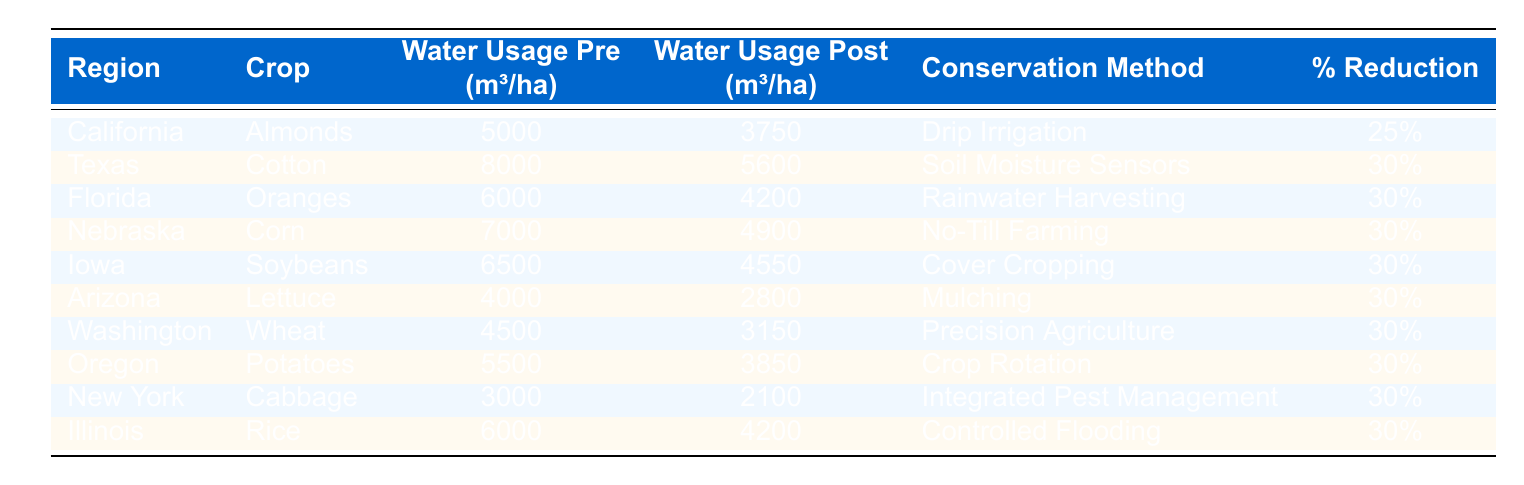What is the water usage per hectare for almonds in California before conservation methods? The table shows that the water usage for almonds in California before conservation methods was 5000 m³/ha.
Answer: 5000 m³/ha What is the percentage reduction in water usage for wheat in Washington after implementing conservation methods? The table indicates that the percentage reduction in water usage for wheat in Washington is 30%.
Answer: 30% Which conservation method resulted in the lowest post-conservation water usage? By analyzing the table, lettuce in Arizona has the lowest post-conservation water usage at 2800 m³/ha.
Answer: 2800 m³/ha What is the average percentage reduction in water usage across all regions listed in the table? To find the average, sum the percentage reductions: 25 + 30 + 30 + 30 + 30 + 30 + 30 + 30 + 30 + 30 =  295, then divide by the number of regions (10), giving an average of 29.5%.
Answer: 29.5% Is the water usage for rice in Illinois higher or lower than that for oranges in Florida after conservation methods? The water usage for rice in Illinois after conservation is 4200 m³/ha, while for oranges it is 4200 m³/ha. Thus, they are equal.
Answer: Equal How much water is saved in cubic meters per hectare for corn in Nebraska after conservation methods? The water usage for corn pre-conservation is 7000 m³/ha and post-conservation is 4900 m³/ha. The difference is 7000 - 4900 = 2100 m³/ha saved.
Answer: 2100 m³/ha Which region has the highest water usage pre-conservation and what is that usage? The table shows Texas has the highest water usage pre-conservation at 8000 m³/ha for cotton.
Answer: 8000 m³/ha What is the total water usage reduction for oranges and rice combined? For oranges, the reduction is 6000 - 4200 = 1800 m³/ha and for rice, it is 6000 - 4200 = 1800 m³/ha. Hence, total reduction is 1800 + 1800 = 3600 m³/ha.
Answer: 3600 m³/ha Which crop in which region experienced the highest water usage reduction percentage? Checking the table, all crops apart from almonds have 30% reduction with the highest water usage being in cotton, so cotton in Texas experienced a reduction of 30%.
Answer: 30% What could be inferred about the effectiveness of 'Drip Irrigation' compared to other conservation methods? 'Drip Irrigation' achieved a 25% reduction for almonds, which is lower than the 30% reduction achieved by other methods; thus, it may be inferred that it is marginally less effective compared to the other methods listed.
Answer: Less effective How does the post-conservation water usage for potatoes in Oregon compare to the pre-conservation usage? The post-conservation water usage for potatoes in Oregon is 3850 m³/ha, while pre-conservation is 5500 m³/ha. The reduction is 5500 - 3850 = 1650 m³/ha, showing a significant decrease.
Answer: 1650 m³/ha 